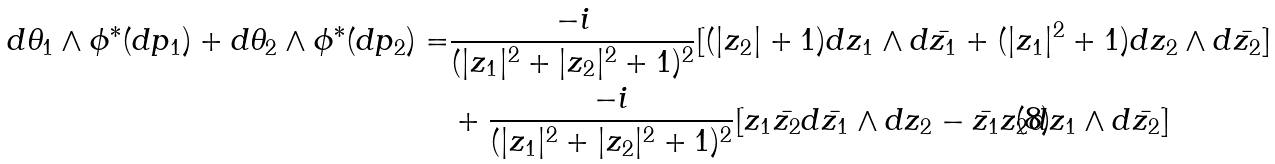<formula> <loc_0><loc_0><loc_500><loc_500>d \theta _ { 1 } \wedge \phi ^ { * } ( d p _ { 1 } ) + d \theta _ { 2 } \wedge \phi ^ { * } ( d p _ { 2 } ) = & \frac { - i } { ( | z _ { 1 } | ^ { 2 } + | z _ { 2 } | ^ { 2 } + 1 ) ^ { 2 } } [ ( | z _ { 2 } | + 1 ) d z _ { 1 } \wedge d \bar { z _ { 1 } } + ( | z _ { 1 } | ^ { 2 } + 1 ) d z _ { 2 } \wedge d \bar { z _ { 2 } } ] \\ & + \frac { - i } { ( | z _ { 1 } | ^ { 2 } + | z _ { 2 } | ^ { 2 } + 1 ) ^ { 2 } } [ z _ { 1 } \bar { z _ { 2 } } d \bar { z _ { 1 } } \wedge d z _ { 2 } - \bar { z _ { 1 } } z _ { 2 } d z _ { 1 } \wedge d \bar { z _ { 2 } } ]</formula> 